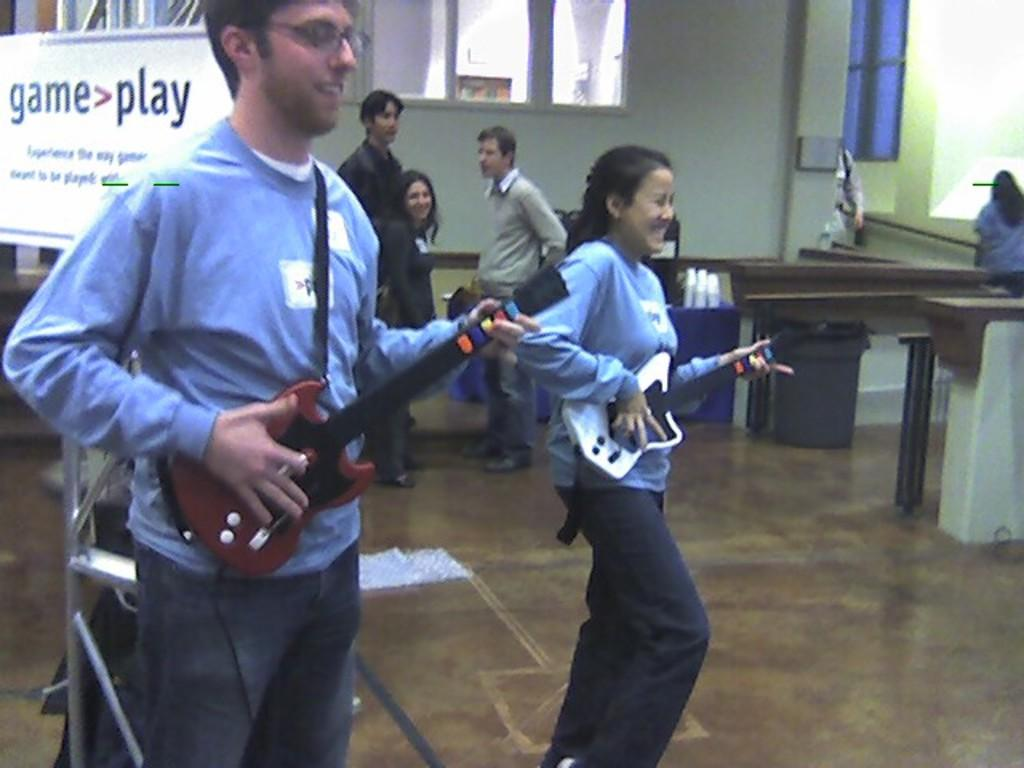What is the main subject of the image? There is a person standing in the center of the image. What is the person holding in the image? The person is holding a guitar. Can you describe the background of the image? There are persons, a dustbin, a table, a board, a wall, and a window in the background of the image. What type of curtain can be seen hanging from the window in the image? There is no curtain visible in the image; only a window is present in the background. 